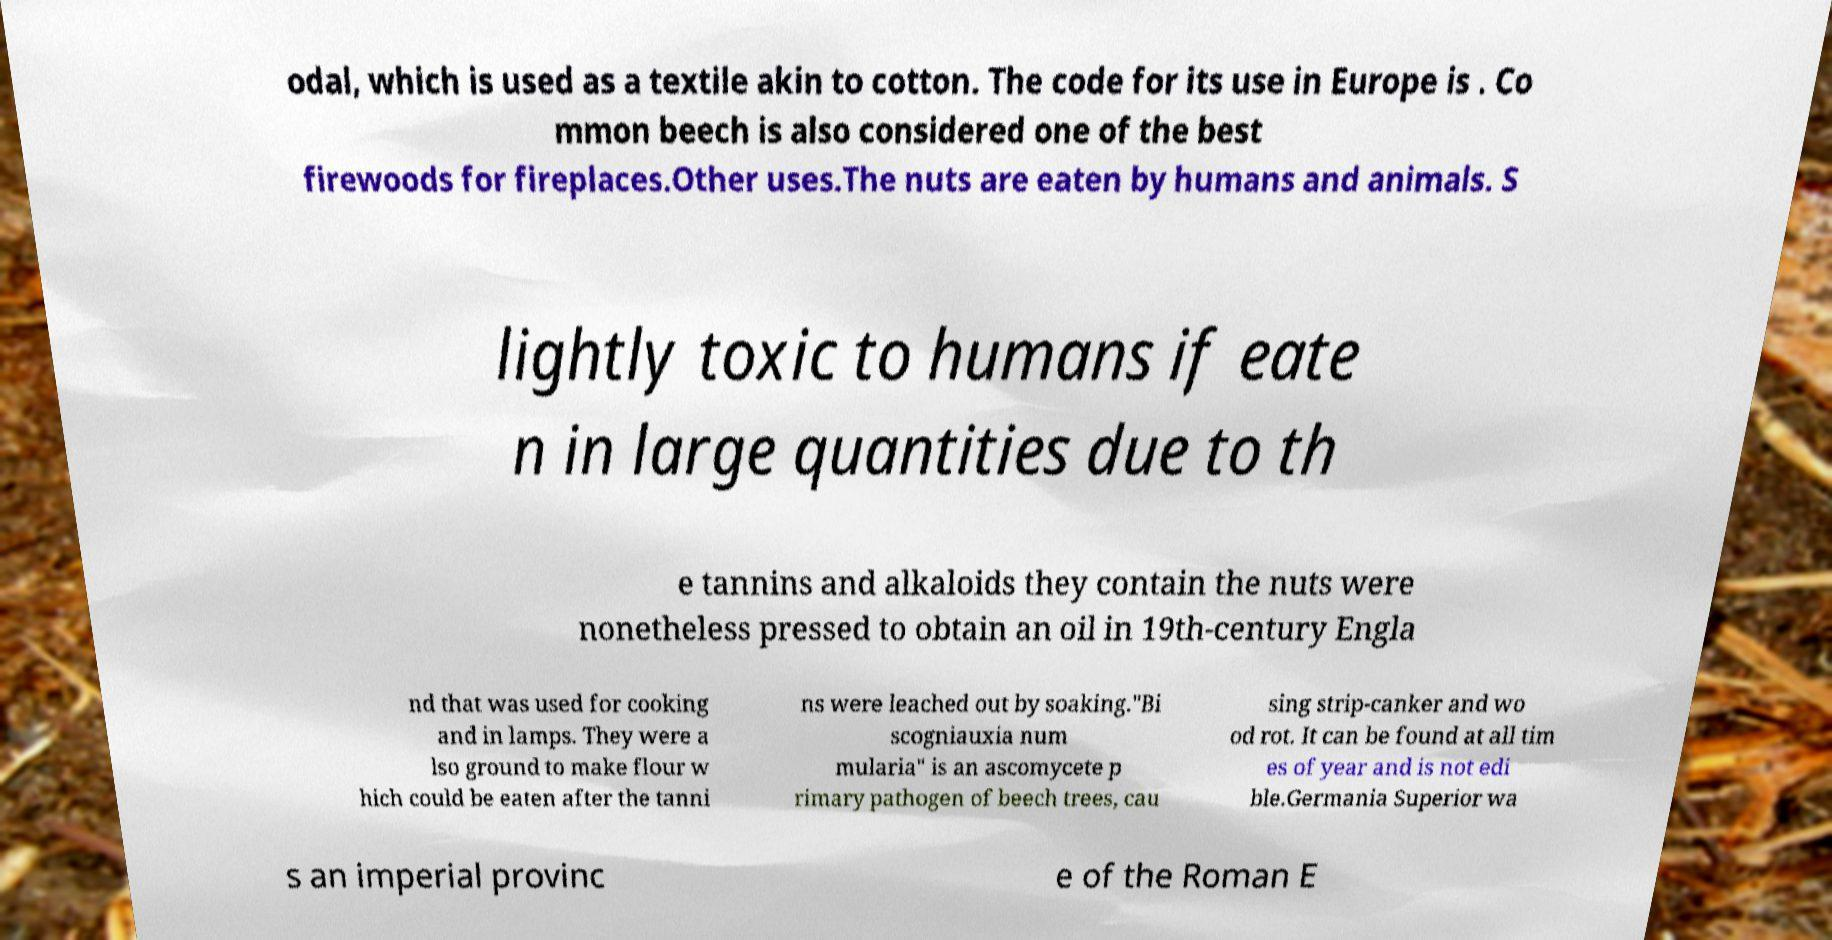There's text embedded in this image that I need extracted. Can you transcribe it verbatim? odal, which is used as a textile akin to cotton. The code for its use in Europe is . Co mmon beech is also considered one of the best firewoods for fireplaces.Other uses.The nuts are eaten by humans and animals. S lightly toxic to humans if eate n in large quantities due to th e tannins and alkaloids they contain the nuts were nonetheless pressed to obtain an oil in 19th-century Engla nd that was used for cooking and in lamps. They were a lso ground to make flour w hich could be eaten after the tanni ns were leached out by soaking."Bi scogniauxia num mularia" is an ascomycete p rimary pathogen of beech trees, cau sing strip-canker and wo od rot. It can be found at all tim es of year and is not edi ble.Germania Superior wa s an imperial provinc e of the Roman E 